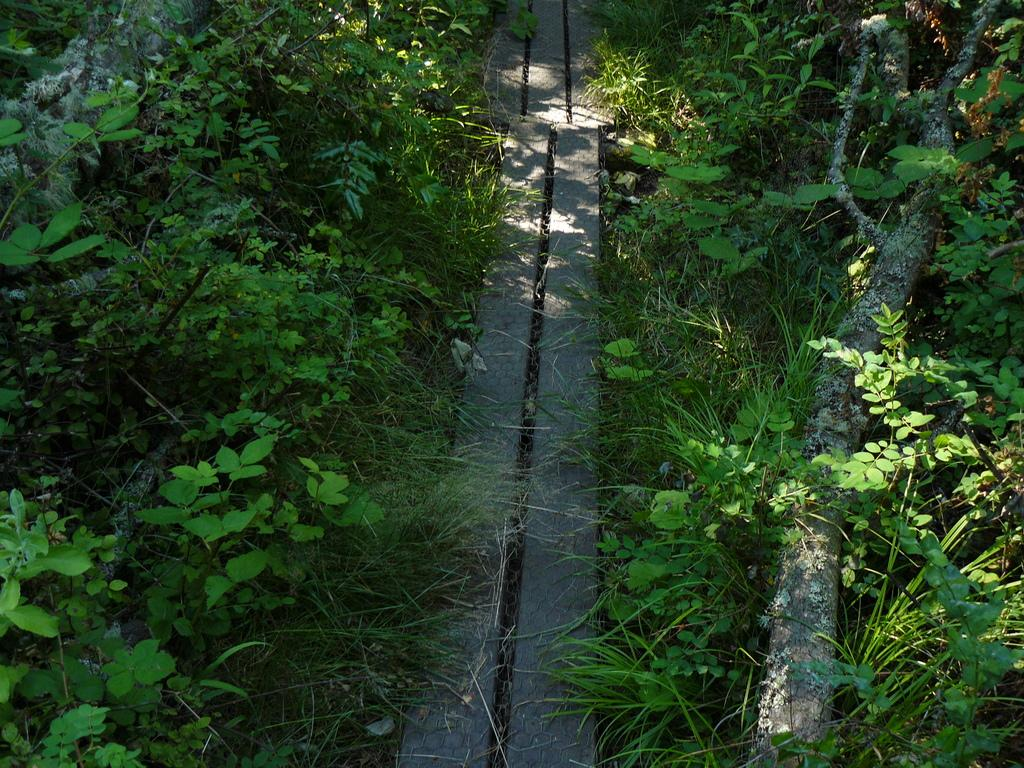What type of material is used for the planks and trunk in the image? The planks and trunk in the image are made of wood. What is the natural covering on the land in the image? The land in the image has grass. What type of vegetation is present in the image? There are plants in the image, and they have leaves. Where is the nearest downtown area in relation to the image? There is no information about a downtown area in the image or the surrounding context, so it cannot be determined. 